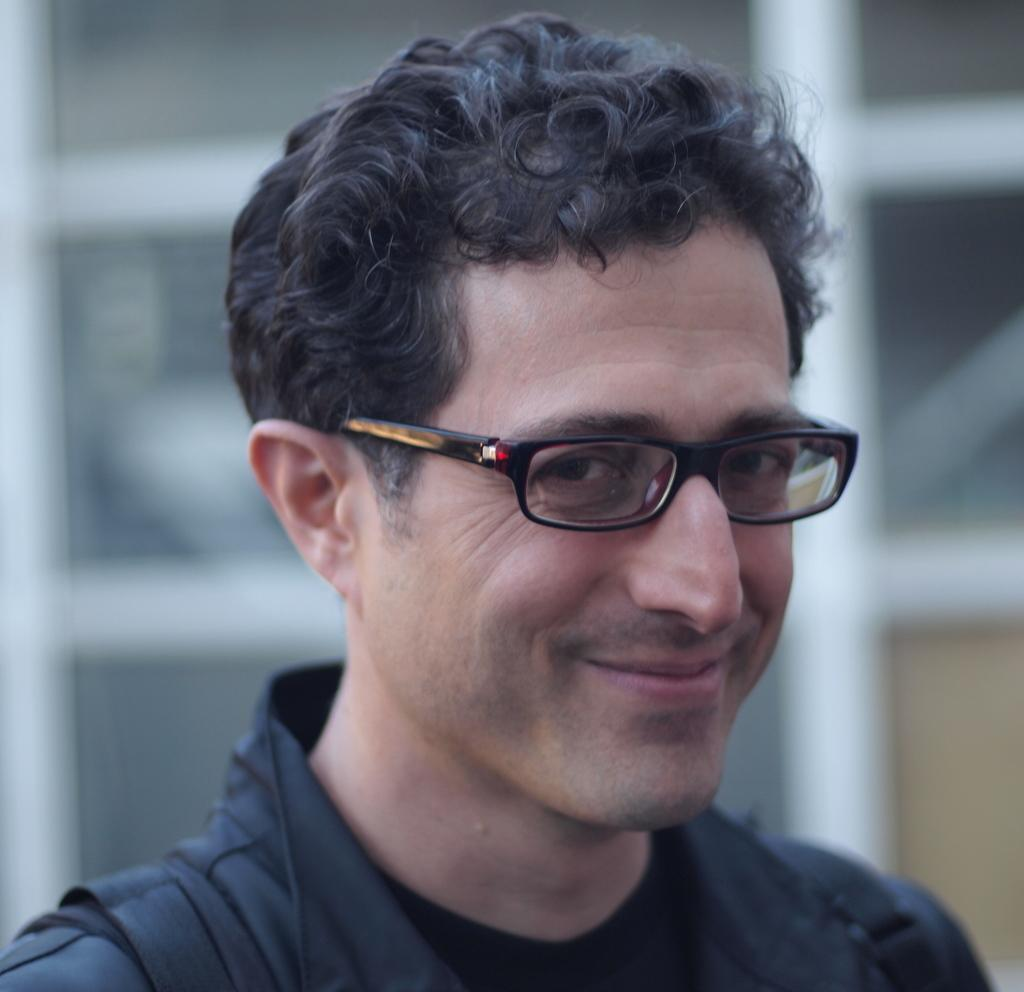Who or what is the main subject of the image? There is a person in the image. What accessory is the person wearing? The person is wearing glasses (specs). What color is the dress the person is wearing? The person is wearing a black dress. Can you describe the background of the image? The background of the image is blurred. What brand of toothpaste is the person using in the image? There is no toothpaste present in the image, and therefore no brand can be identified. Can you tell me how many sheep are visible in the image? There are no sheep present in the image. --- 